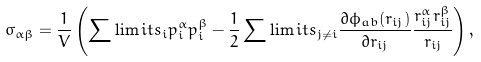Convert formula to latex. <formula><loc_0><loc_0><loc_500><loc_500>\sigma _ { \alpha \beta } = \frac { 1 } { V } \left ( \sum \lim i t s _ { i } p ^ { \alpha } _ { i } p ^ { \beta } _ { i } - \frac { 1 } { 2 } \sum \lim i t s _ { j \ne i } \frac { \partial \phi _ { a b } ( r _ { i j } ) } { \partial r _ { i j } } \frac { r ^ { \alpha } _ { i j } r ^ { \beta } _ { i j } } { r _ { i j } } \right ) ,</formula> 